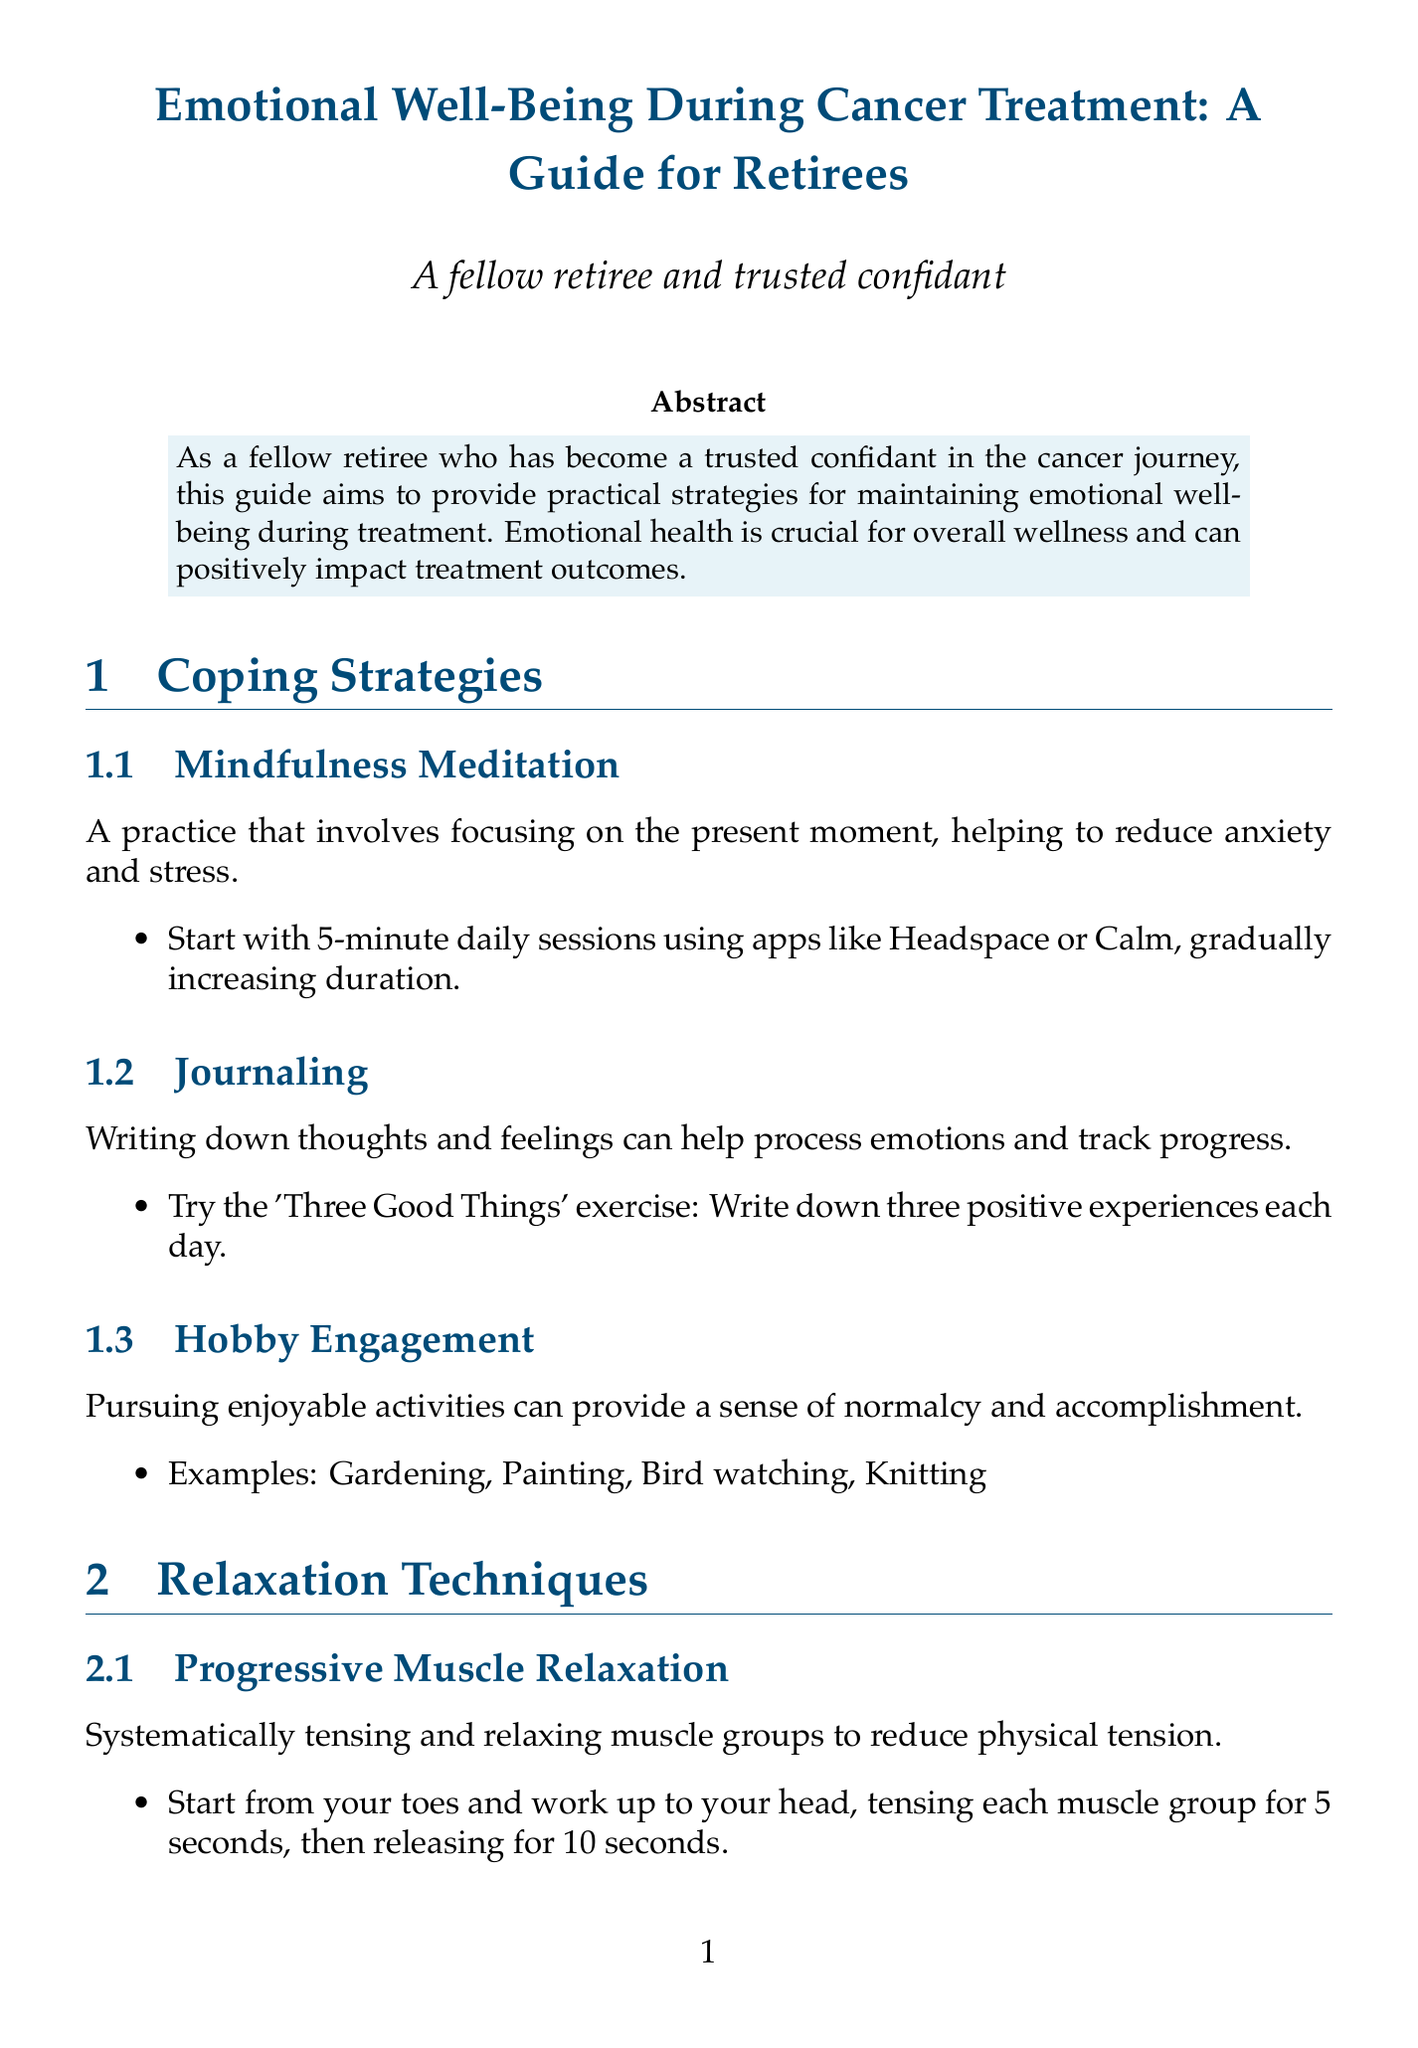What is the title of the guide? The title of the guide provides the main focus of the content, which is about maintaining emotional well-being during cancer treatment specifically for retirees.
Answer: Emotional Well-Being During Cancer Treatment: A Guide for Retirees What are the three examples of hobbies mentioned for engagement? This asks for specific enjoyable activities that retirees can pursue to maintain normalcy and accomplishment during treatment.
Answer: Gardening, Painting, Bird watching, Knitting How many counts do you inhale during the 4-7-8 breathing technique? This focuses on a specific detail concerning the breathing exercise provided in the relaxation techniques.
Answer: 4 counts What does the American Cancer Society offer regarding guided imagery? This asks about the resources provided by a well-known organization for cancer support, specifically related to relaxation techniques.
Answer: Free guided imagery recordings Which counseling service provides professional counseling by phone or online? This queries a specific service offered to help individuals cope emotionally during cancer treatment.
Answer: CancerCare What is the importance of emotional health mentioned in the introduction? This question requires understanding of the content's emphasis on the role of emotional well-being in overall wellness and treatment outcomes.
Answer: Crucial for overall wellness and can positively impact treatment outcomes Which organization offers 24/7 support for cancer-related questions? This question identifies a specific resource available for retirees seeking immediate assistance and information related to cancer.
Answer: American Cancer Society's Helpline What is one suggested physical activity during cancer treatment? This question looks for a specific suggestion concerning maintaining physical health during treatment, contributing to emotional well-being.
Answer: Gentle yoga 